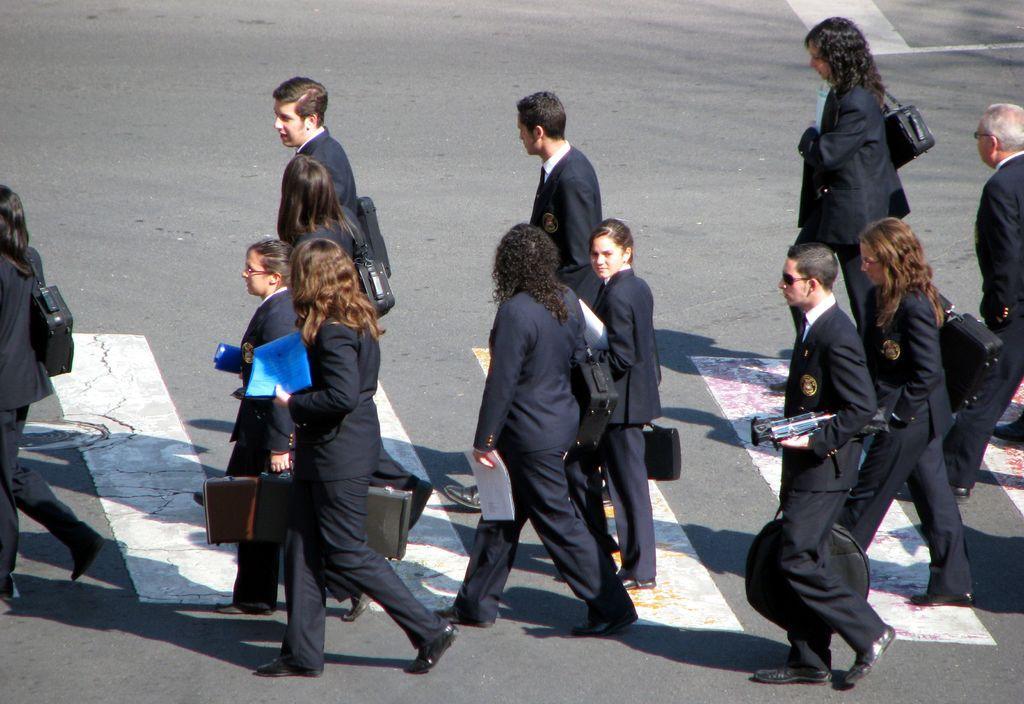Describe this image in one or two sentences. In this image, we can see a group of people are walking on the road. Here we can see a pedestrian crossing. Few people are holding some objects and wearing bags. 